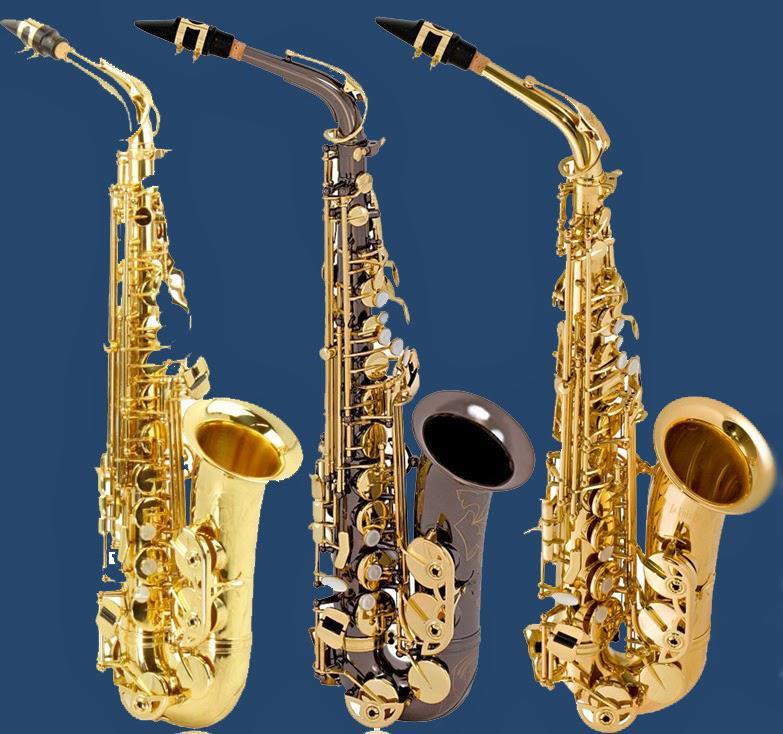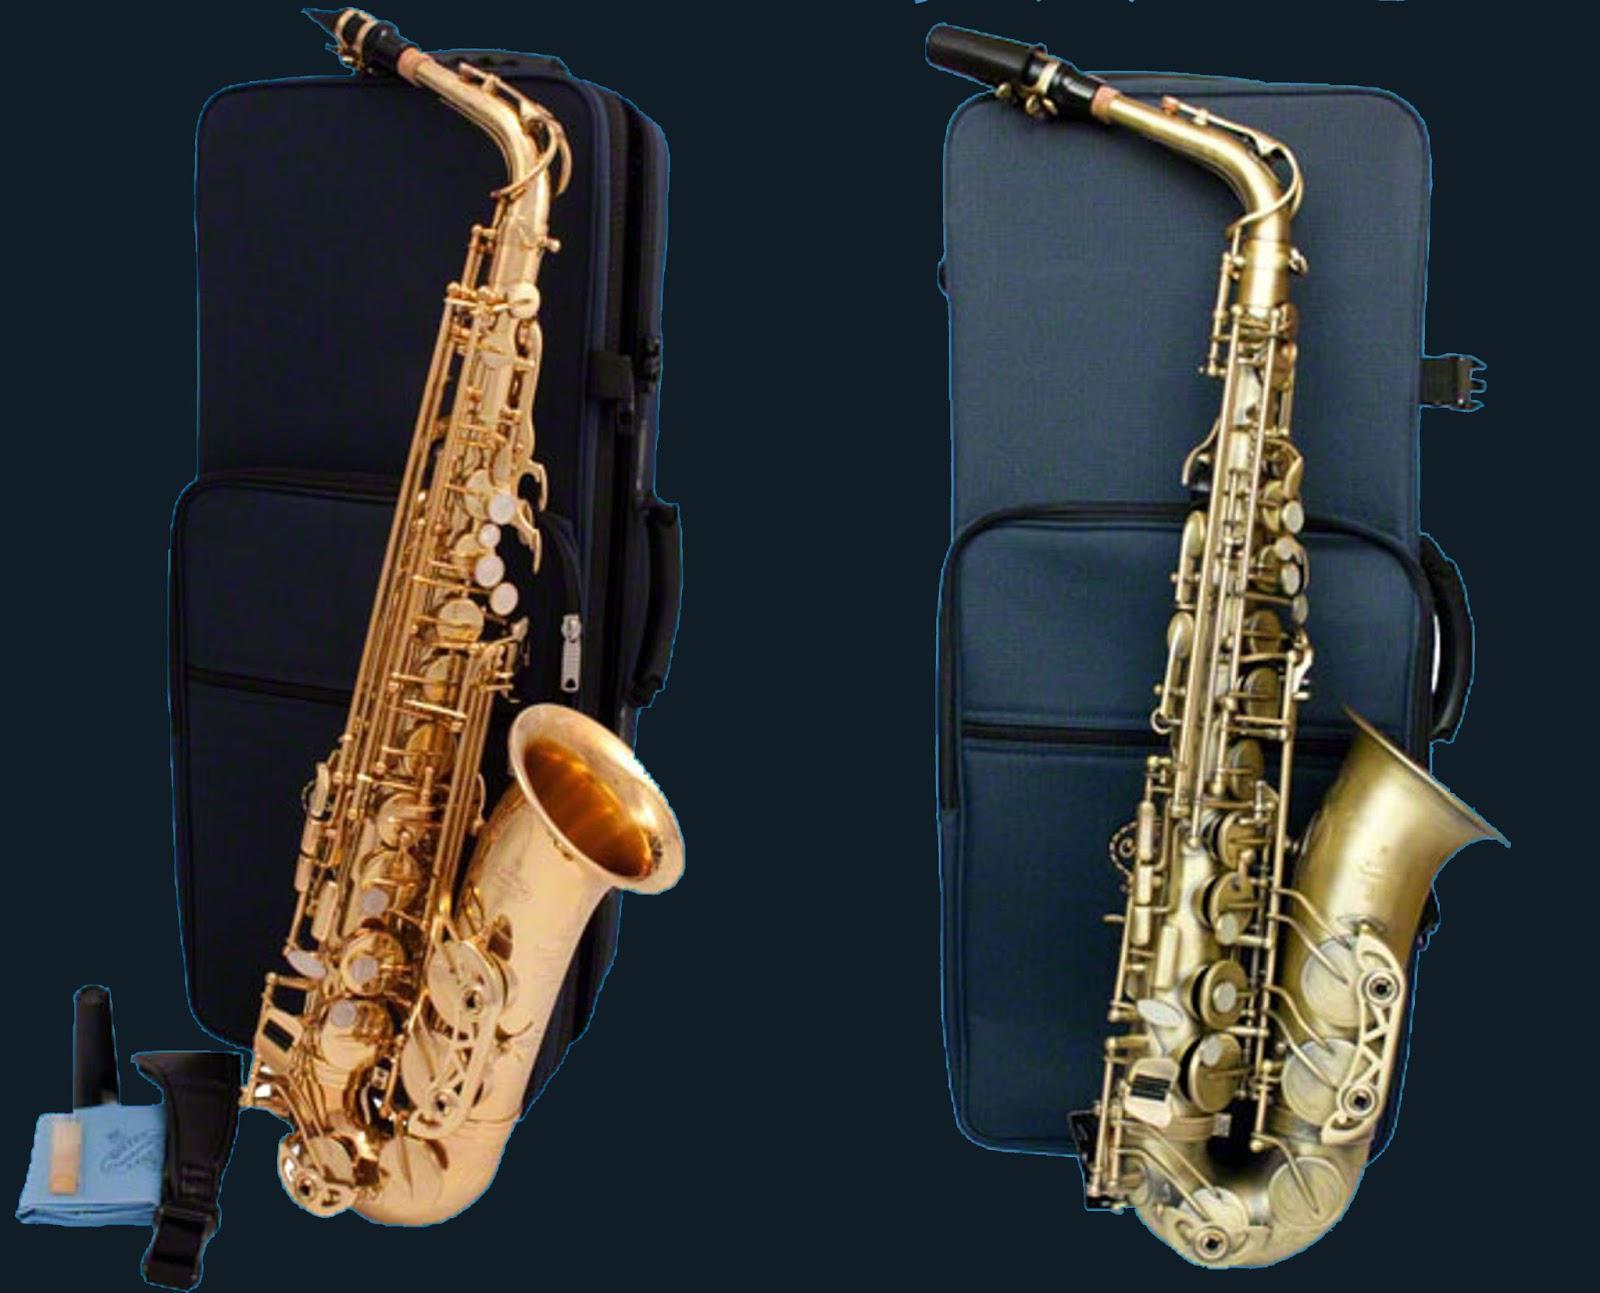The first image is the image on the left, the second image is the image on the right. Evaluate the accuracy of this statement regarding the images: "There are no more than 3 saxophones.". Is it true? Answer yes or no. No. The first image is the image on the left, the second image is the image on the right. Given the left and right images, does the statement "There are more than four saxophones in total." hold true? Answer yes or no. Yes. 